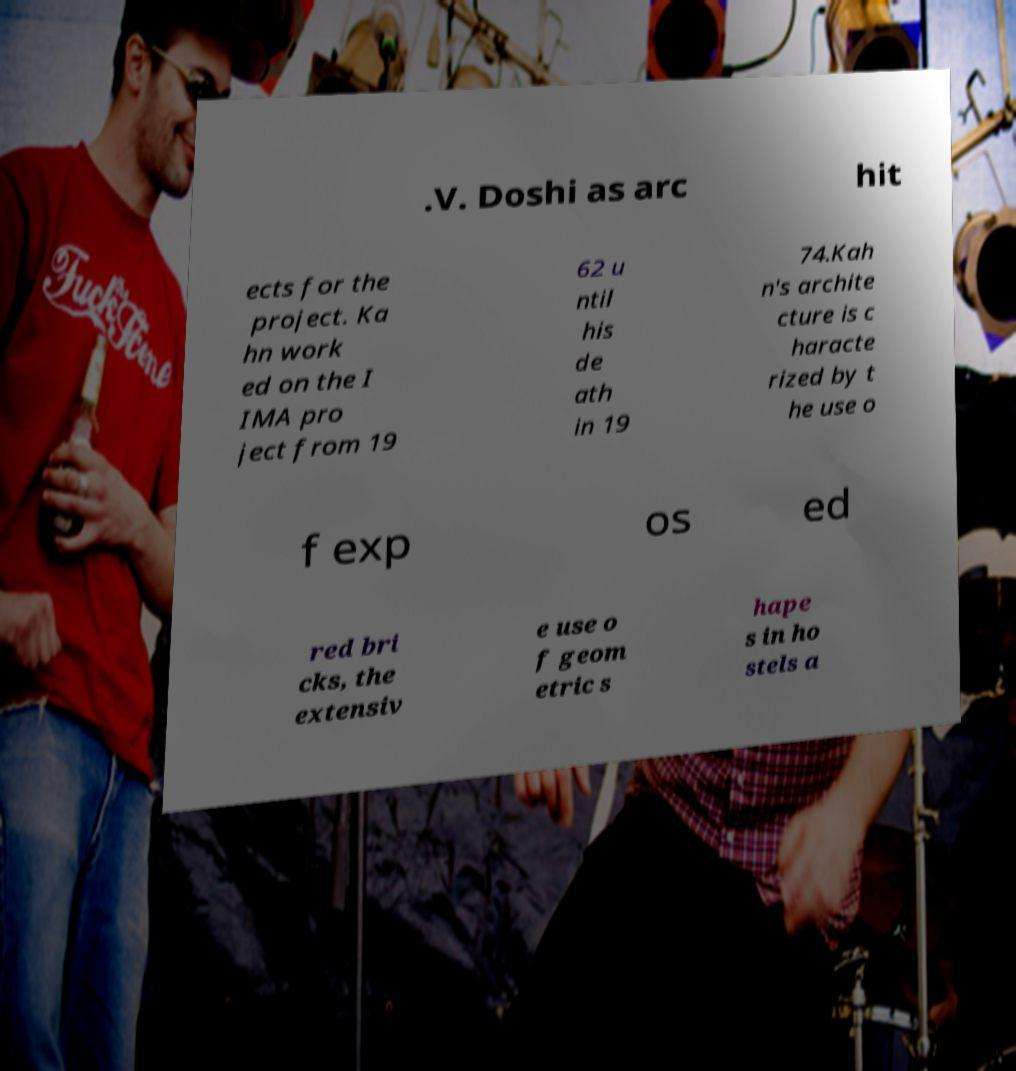Could you assist in decoding the text presented in this image and type it out clearly? .V. Doshi as arc hit ects for the project. Ka hn work ed on the I IMA pro ject from 19 62 u ntil his de ath in 19 74.Kah n's archite cture is c haracte rized by t he use o f exp os ed red bri cks, the extensiv e use o f geom etric s hape s in ho stels a 